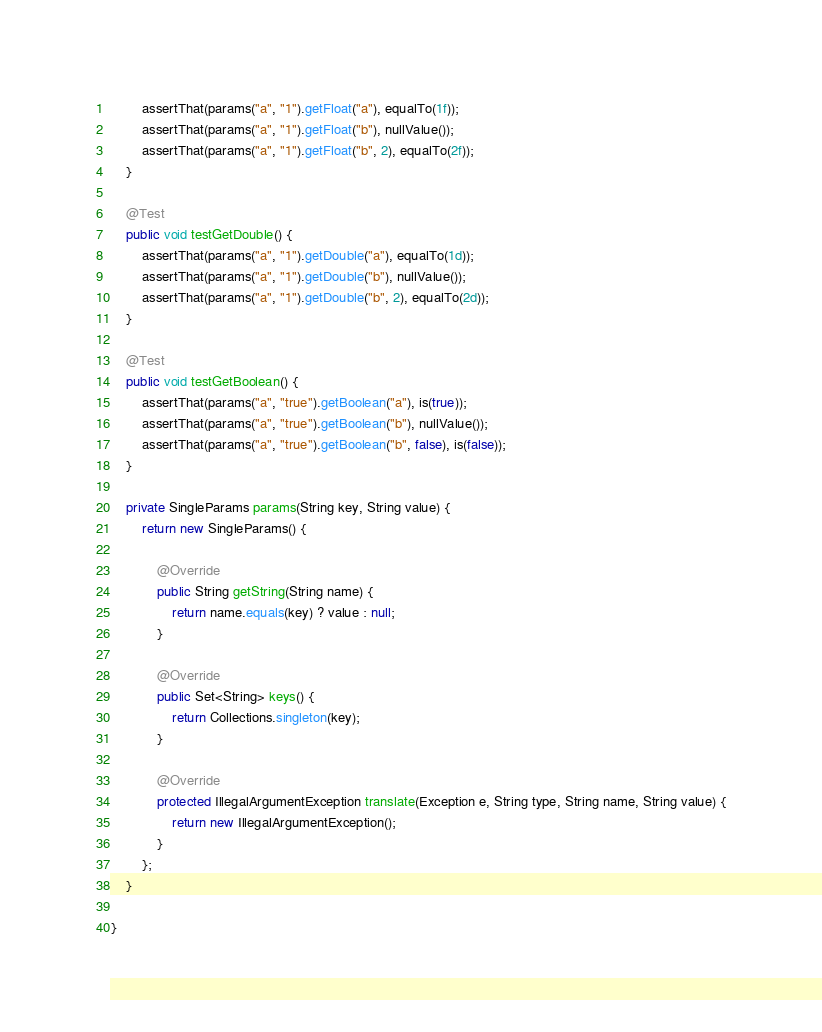<code> <loc_0><loc_0><loc_500><loc_500><_Java_>        assertThat(params("a", "1").getFloat("a"), equalTo(1f));
        assertThat(params("a", "1").getFloat("b"), nullValue());
        assertThat(params("a", "1").getFloat("b", 2), equalTo(2f));
    }

    @Test
    public void testGetDouble() {
        assertThat(params("a", "1").getDouble("a"), equalTo(1d));
        assertThat(params("a", "1").getDouble("b"), nullValue());
        assertThat(params("a", "1").getDouble("b", 2), equalTo(2d));
    }

    @Test
    public void testGetBoolean() {
        assertThat(params("a", "true").getBoolean("a"), is(true));
        assertThat(params("a", "true").getBoolean("b"), nullValue());
        assertThat(params("a", "true").getBoolean("b", false), is(false));
    }

    private SingleParams params(String key, String value) {
        return new SingleParams() {

            @Override
            public String getString(String name) {
                return name.equals(key) ? value : null;
            }

            @Override
            public Set<String> keys() {
                return Collections.singleton(key);
            }

            @Override
            protected IllegalArgumentException translate(Exception e, String type, String name, String value) {
                return new IllegalArgumentException();
            }
        };
    }

}
</code> 